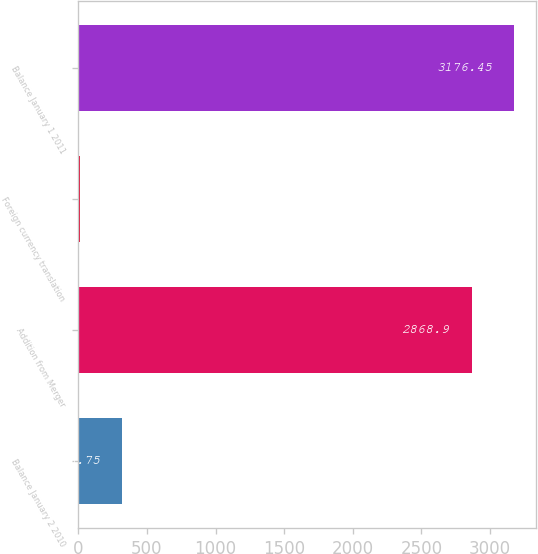Convert chart to OTSL. <chart><loc_0><loc_0><loc_500><loc_500><bar_chart><fcel>Balance January 2 2010<fcel>Addition from Merger<fcel>Foreign currency translation<fcel>Balance January 1 2011<nl><fcel>318.75<fcel>2868.9<fcel>11.2<fcel>3176.45<nl></chart> 